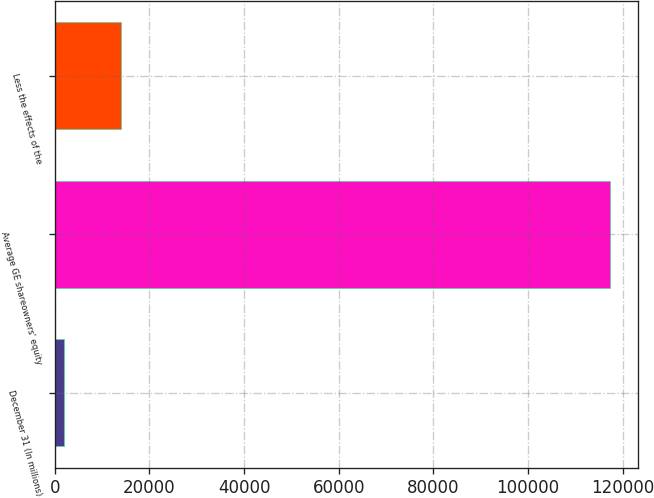Convert chart to OTSL. <chart><loc_0><loc_0><loc_500><loc_500><bar_chart><fcel>December 31 (In millions)<fcel>Average GE shareowners' equity<fcel>Less the effects of the<nl><fcel>2011<fcel>117365<fcel>14038.8<nl></chart> 